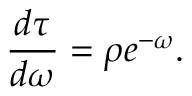Convert formula to latex. <formula><loc_0><loc_0><loc_500><loc_500>\frac { d \tau } { d \omega } = \rho e ^ { - \omega } .</formula> 